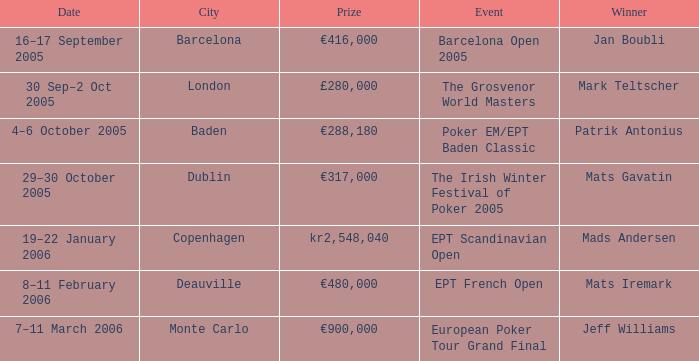What event did Mark Teltscher win? The Grosvenor World Masters. 